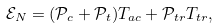<formula> <loc_0><loc_0><loc_500><loc_500>\mathcal { E } _ { N } = ( \mathcal { P } _ { c } + \mathcal { P } _ { t } ) T _ { a c } + \mathcal { P } _ { t r } T _ { t r } ,</formula> 